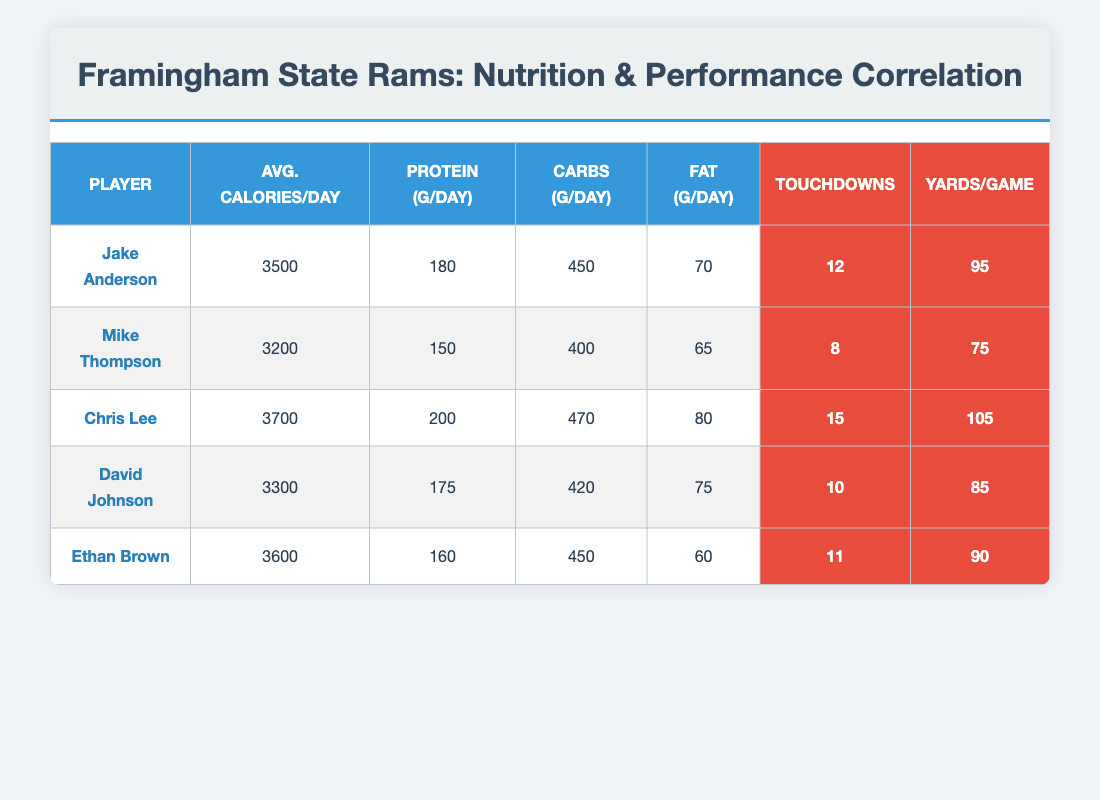What is the average protein intake per day among the players? To find the average protein intake, add the protein intakes: (180 + 150 + 200 + 175 + 160) = 965 grams. Divide by the number of players (5), so 965 / 5 = 193 grams/day.
Answer: 193 grams/day Which player had the highest number of touchdowns last season? Looking through the touchdowns column, Chris Lee has the highest number with 15 touchdowns.
Answer: Chris Lee Is the average calorie intake for the players greater than 3400 calories per day? Calculate the average calorie intake: (3500 + 3200 + 3700 + 3300 + 3600) = 17300 calories. Divide by the number of players (5) gives 17300 / 5 = 3460 calories. Since 3460 is greater than 3400, the answer is yes.
Answer: Yes How many total yards did Jake Anderson gain per game compared to the average yards gained by all players? Jake Anderson gained 95 yards per game. To find the average, sum the yards: (95 + 75 + 105 + 85 + 90) = 450 yards. Divide by 5 players gives 450 / 5 = 90 yards per game. Jake Anderson gained 5 more yards than the average (95 - 90 = 5).
Answer: 5 yards Are there more players with a daily protein intake of 175 grams or less than those with a higher intake? Players with 175 grams or less: Mike Thompson (150), Ethan Brown (160), David Johnson (175); total = 3 players. Players with higher than 175 grams: Jake Anderson (180), Chris Lee (200); total = 2 players. Since 3 is greater than 2, the answer is yes.
Answer: Yes What is the relationship between carbohydrate intake and touchdowns? Specifically, how many carbohydrates does Chris Lee consume, and what is his touchdown count? Chris Lee has a carbohydrate intake of 470 grams per day and scored 15 touchdowns. To analyze the relationship: High carbohydrate intake correlates with a high number of touchdowns, suggesting a positive trend.
Answer: 470 grams, 15 touchdowns What fat intake range is observed for players who scored more than 10 touchdowns? Players who scored more than 10 touchdowns: Chris Lee (80 grams), Jake Anderson (70 grams), and Ethan Brown (60 grams). The fat intake range is from 60 to 80 grams. Therefore, the fat intake range observed is 60-80 grams.
Answer: 60-80 grams Which player had the lowest yards per game and how many were they? Scanning the yards per game column, Mike Thompson has the lowest yards per game with 75 yards.
Answer: 75 yards How much more does David Johnson consume in total calories compared to Mike Thompson? David Johnson consumes 3300 calories per day while Mike Thompson consumes 3200 calories. The difference is 3300 - 3200 = 100 calories.
Answer: 100 calories 